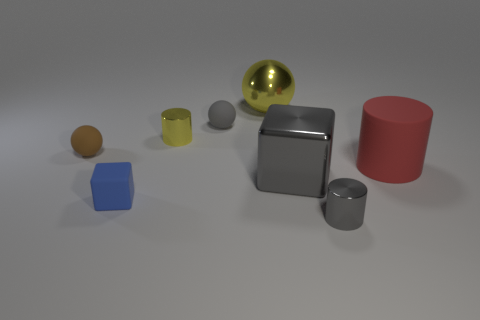Subtract all big shiny spheres. How many spheres are left? 2 Add 2 purple metallic objects. How many objects exist? 10 Subtract all red cylinders. How many cylinders are left? 2 Subtract all spheres. How many objects are left? 5 Add 8 gray matte objects. How many gray matte objects exist? 9 Subtract 1 gray blocks. How many objects are left? 7 Subtract all yellow balls. Subtract all yellow cylinders. How many balls are left? 2 Subtract all big yellow spheres. Subtract all gray shiny blocks. How many objects are left? 6 Add 2 yellow metal things. How many yellow metal things are left? 4 